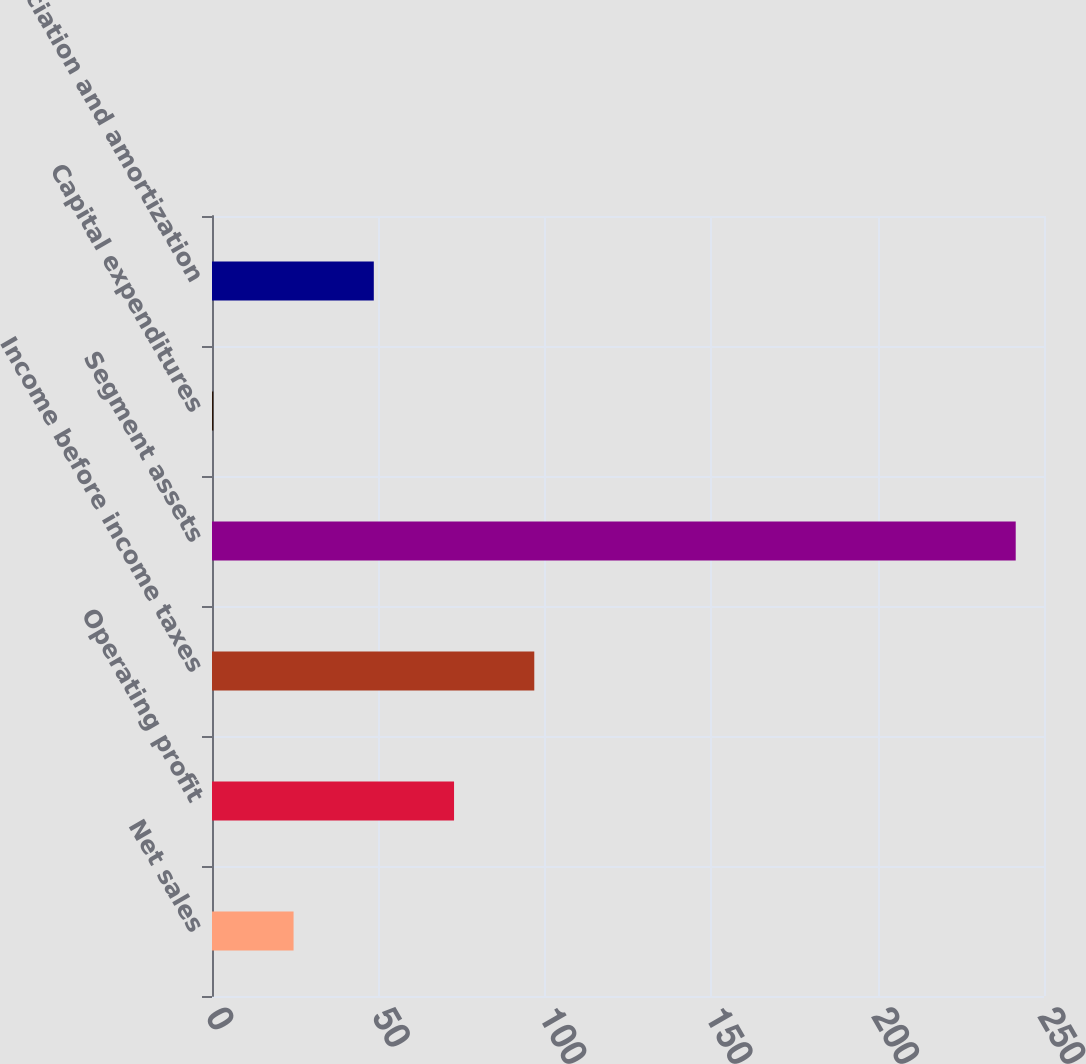Convert chart to OTSL. <chart><loc_0><loc_0><loc_500><loc_500><bar_chart><fcel>Net sales<fcel>Operating profit<fcel>Income before income taxes<fcel>Segment assets<fcel>Capital expenditures<fcel>Depreciation and amortization<nl><fcel>24.51<fcel>72.73<fcel>96.84<fcel>241.5<fcel>0.4<fcel>48.62<nl></chart> 